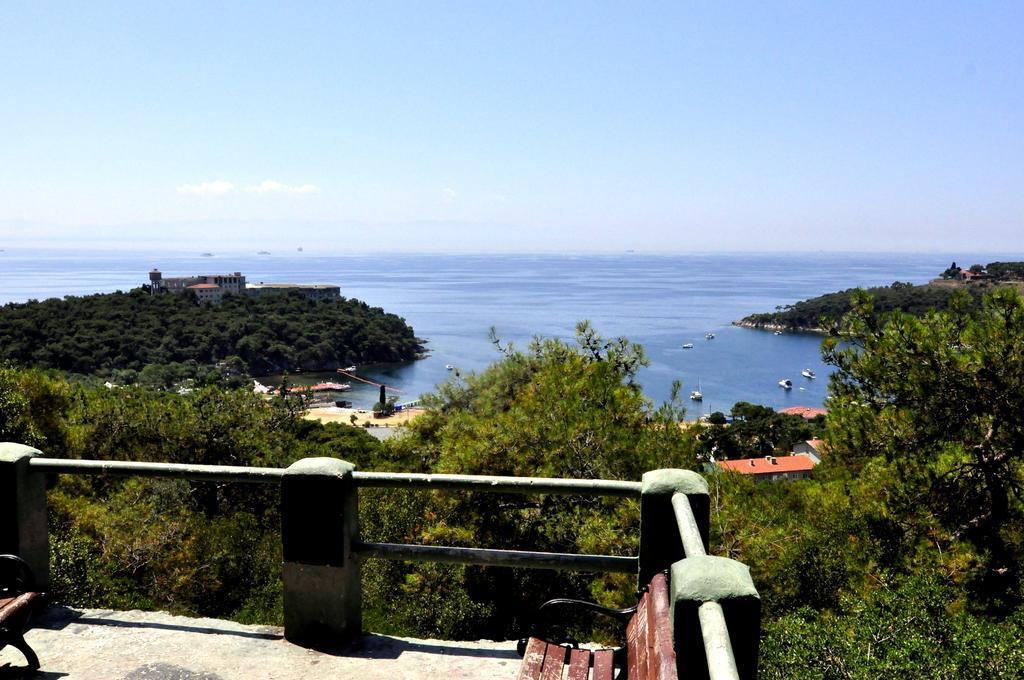How would you summarize this image in a sentence or two? In this image we can see ocean, ships, hills, buildings, trees, sky with clouds, benches on the floor and grills. 